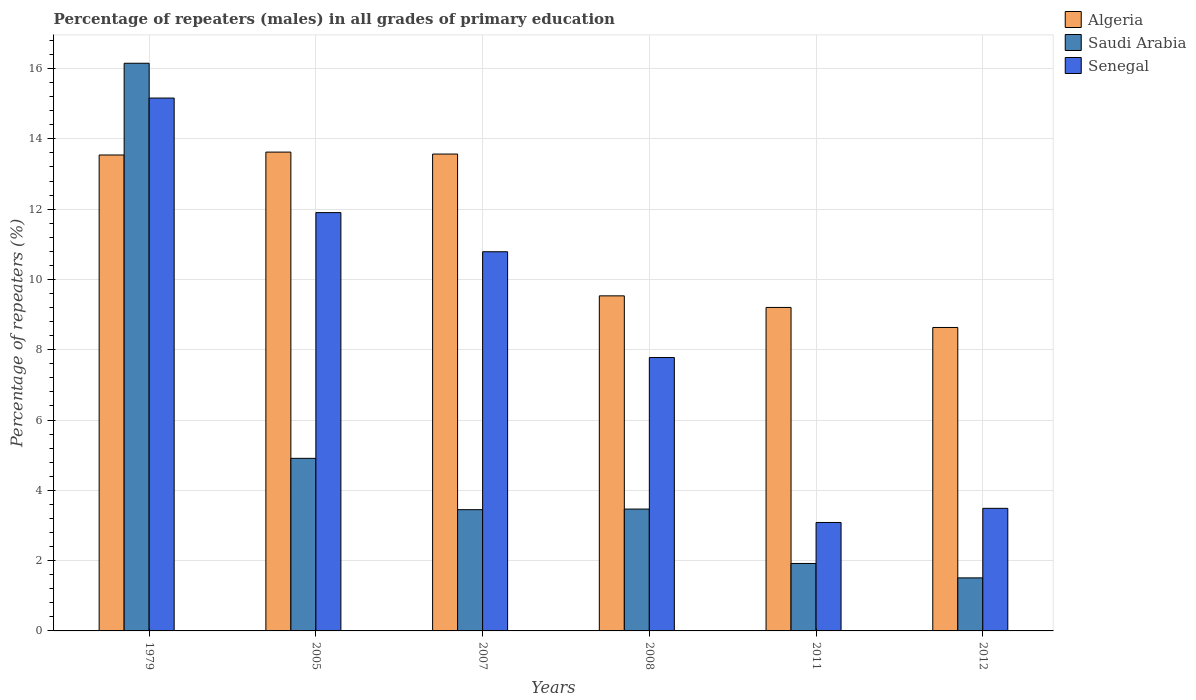How many groups of bars are there?
Ensure brevity in your answer.  6. Are the number of bars per tick equal to the number of legend labels?
Your answer should be compact. Yes. How many bars are there on the 1st tick from the left?
Offer a very short reply. 3. In how many cases, is the number of bars for a given year not equal to the number of legend labels?
Offer a very short reply. 0. What is the percentage of repeaters (males) in Senegal in 2007?
Provide a succinct answer. 10.79. Across all years, what is the maximum percentage of repeaters (males) in Senegal?
Give a very brief answer. 15.16. Across all years, what is the minimum percentage of repeaters (males) in Senegal?
Offer a very short reply. 3.09. In which year was the percentage of repeaters (males) in Algeria maximum?
Your answer should be very brief. 2005. What is the total percentage of repeaters (males) in Algeria in the graph?
Provide a succinct answer. 68.11. What is the difference between the percentage of repeaters (males) in Algeria in 2008 and that in 2012?
Provide a succinct answer. 0.9. What is the difference between the percentage of repeaters (males) in Saudi Arabia in 2011 and the percentage of repeaters (males) in Algeria in 2007?
Provide a short and direct response. -11.65. What is the average percentage of repeaters (males) in Senegal per year?
Your answer should be very brief. 8.7. In the year 2007, what is the difference between the percentage of repeaters (males) in Senegal and percentage of repeaters (males) in Algeria?
Your answer should be very brief. -2.78. In how many years, is the percentage of repeaters (males) in Senegal greater than 11.6 %?
Your response must be concise. 2. What is the ratio of the percentage of repeaters (males) in Saudi Arabia in 2008 to that in 2012?
Give a very brief answer. 2.3. Is the percentage of repeaters (males) in Algeria in 1979 less than that in 2008?
Ensure brevity in your answer.  No. Is the difference between the percentage of repeaters (males) in Senegal in 2008 and 2012 greater than the difference between the percentage of repeaters (males) in Algeria in 2008 and 2012?
Your answer should be very brief. Yes. What is the difference between the highest and the second highest percentage of repeaters (males) in Senegal?
Your answer should be very brief. 3.26. What is the difference between the highest and the lowest percentage of repeaters (males) in Algeria?
Offer a terse response. 4.99. In how many years, is the percentage of repeaters (males) in Senegal greater than the average percentage of repeaters (males) in Senegal taken over all years?
Offer a very short reply. 3. What does the 1st bar from the left in 2008 represents?
Your answer should be very brief. Algeria. What does the 2nd bar from the right in 2007 represents?
Your answer should be compact. Saudi Arabia. How many years are there in the graph?
Give a very brief answer. 6. Are the values on the major ticks of Y-axis written in scientific E-notation?
Give a very brief answer. No. Where does the legend appear in the graph?
Ensure brevity in your answer.  Top right. How many legend labels are there?
Give a very brief answer. 3. How are the legend labels stacked?
Offer a terse response. Vertical. What is the title of the graph?
Provide a succinct answer. Percentage of repeaters (males) in all grades of primary education. What is the label or title of the X-axis?
Give a very brief answer. Years. What is the label or title of the Y-axis?
Keep it short and to the point. Percentage of repeaters (%). What is the Percentage of repeaters (%) in Algeria in 1979?
Provide a succinct answer. 13.54. What is the Percentage of repeaters (%) of Saudi Arabia in 1979?
Your response must be concise. 16.15. What is the Percentage of repeaters (%) in Senegal in 1979?
Offer a very short reply. 15.16. What is the Percentage of repeaters (%) of Algeria in 2005?
Provide a short and direct response. 13.62. What is the Percentage of repeaters (%) in Saudi Arabia in 2005?
Your response must be concise. 4.91. What is the Percentage of repeaters (%) of Senegal in 2005?
Provide a succinct answer. 11.9. What is the Percentage of repeaters (%) in Algeria in 2007?
Offer a very short reply. 13.57. What is the Percentage of repeaters (%) in Saudi Arabia in 2007?
Make the answer very short. 3.45. What is the Percentage of repeaters (%) of Senegal in 2007?
Ensure brevity in your answer.  10.79. What is the Percentage of repeaters (%) of Algeria in 2008?
Your answer should be very brief. 9.53. What is the Percentage of repeaters (%) of Saudi Arabia in 2008?
Make the answer very short. 3.47. What is the Percentage of repeaters (%) of Senegal in 2008?
Your answer should be very brief. 7.78. What is the Percentage of repeaters (%) in Algeria in 2011?
Offer a very short reply. 9.2. What is the Percentage of repeaters (%) in Saudi Arabia in 2011?
Offer a terse response. 1.92. What is the Percentage of repeaters (%) in Senegal in 2011?
Offer a terse response. 3.09. What is the Percentage of repeaters (%) in Algeria in 2012?
Offer a very short reply. 8.63. What is the Percentage of repeaters (%) in Saudi Arabia in 2012?
Provide a short and direct response. 1.51. What is the Percentage of repeaters (%) of Senegal in 2012?
Ensure brevity in your answer.  3.49. Across all years, what is the maximum Percentage of repeaters (%) in Algeria?
Give a very brief answer. 13.62. Across all years, what is the maximum Percentage of repeaters (%) of Saudi Arabia?
Your response must be concise. 16.15. Across all years, what is the maximum Percentage of repeaters (%) in Senegal?
Your answer should be compact. 15.16. Across all years, what is the minimum Percentage of repeaters (%) of Algeria?
Your answer should be very brief. 8.63. Across all years, what is the minimum Percentage of repeaters (%) of Saudi Arabia?
Make the answer very short. 1.51. Across all years, what is the minimum Percentage of repeaters (%) in Senegal?
Provide a short and direct response. 3.09. What is the total Percentage of repeaters (%) of Algeria in the graph?
Offer a terse response. 68.11. What is the total Percentage of repeaters (%) of Saudi Arabia in the graph?
Your answer should be very brief. 31.41. What is the total Percentage of repeaters (%) of Senegal in the graph?
Keep it short and to the point. 52.21. What is the difference between the Percentage of repeaters (%) of Algeria in 1979 and that in 2005?
Your response must be concise. -0.08. What is the difference between the Percentage of repeaters (%) of Saudi Arabia in 1979 and that in 2005?
Offer a terse response. 11.24. What is the difference between the Percentage of repeaters (%) of Senegal in 1979 and that in 2005?
Provide a short and direct response. 3.26. What is the difference between the Percentage of repeaters (%) in Algeria in 1979 and that in 2007?
Provide a short and direct response. -0.03. What is the difference between the Percentage of repeaters (%) in Saudi Arabia in 1979 and that in 2007?
Offer a very short reply. 12.7. What is the difference between the Percentage of repeaters (%) of Senegal in 1979 and that in 2007?
Keep it short and to the point. 4.37. What is the difference between the Percentage of repeaters (%) of Algeria in 1979 and that in 2008?
Your answer should be very brief. 4.01. What is the difference between the Percentage of repeaters (%) in Saudi Arabia in 1979 and that in 2008?
Offer a very short reply. 12.68. What is the difference between the Percentage of repeaters (%) of Senegal in 1979 and that in 2008?
Provide a short and direct response. 7.38. What is the difference between the Percentage of repeaters (%) of Algeria in 1979 and that in 2011?
Make the answer very short. 4.34. What is the difference between the Percentage of repeaters (%) of Saudi Arabia in 1979 and that in 2011?
Your answer should be compact. 14.23. What is the difference between the Percentage of repeaters (%) in Senegal in 1979 and that in 2011?
Offer a terse response. 12.08. What is the difference between the Percentage of repeaters (%) in Algeria in 1979 and that in 2012?
Provide a short and direct response. 4.91. What is the difference between the Percentage of repeaters (%) of Saudi Arabia in 1979 and that in 2012?
Offer a terse response. 14.64. What is the difference between the Percentage of repeaters (%) in Senegal in 1979 and that in 2012?
Offer a terse response. 11.67. What is the difference between the Percentage of repeaters (%) in Algeria in 2005 and that in 2007?
Offer a terse response. 0.06. What is the difference between the Percentage of repeaters (%) of Saudi Arabia in 2005 and that in 2007?
Make the answer very short. 1.46. What is the difference between the Percentage of repeaters (%) of Senegal in 2005 and that in 2007?
Keep it short and to the point. 1.11. What is the difference between the Percentage of repeaters (%) in Algeria in 2005 and that in 2008?
Ensure brevity in your answer.  4.09. What is the difference between the Percentage of repeaters (%) of Saudi Arabia in 2005 and that in 2008?
Your answer should be very brief. 1.44. What is the difference between the Percentage of repeaters (%) of Senegal in 2005 and that in 2008?
Ensure brevity in your answer.  4.12. What is the difference between the Percentage of repeaters (%) in Algeria in 2005 and that in 2011?
Offer a very short reply. 4.42. What is the difference between the Percentage of repeaters (%) in Saudi Arabia in 2005 and that in 2011?
Offer a very short reply. 2.99. What is the difference between the Percentage of repeaters (%) in Senegal in 2005 and that in 2011?
Give a very brief answer. 8.82. What is the difference between the Percentage of repeaters (%) of Algeria in 2005 and that in 2012?
Your answer should be compact. 4.99. What is the difference between the Percentage of repeaters (%) of Saudi Arabia in 2005 and that in 2012?
Make the answer very short. 3.4. What is the difference between the Percentage of repeaters (%) of Senegal in 2005 and that in 2012?
Keep it short and to the point. 8.41. What is the difference between the Percentage of repeaters (%) of Algeria in 2007 and that in 2008?
Your answer should be compact. 4.03. What is the difference between the Percentage of repeaters (%) of Saudi Arabia in 2007 and that in 2008?
Your answer should be very brief. -0.02. What is the difference between the Percentage of repeaters (%) in Senegal in 2007 and that in 2008?
Give a very brief answer. 3.01. What is the difference between the Percentage of repeaters (%) of Algeria in 2007 and that in 2011?
Give a very brief answer. 4.36. What is the difference between the Percentage of repeaters (%) of Saudi Arabia in 2007 and that in 2011?
Your response must be concise. 1.53. What is the difference between the Percentage of repeaters (%) in Senegal in 2007 and that in 2011?
Give a very brief answer. 7.7. What is the difference between the Percentage of repeaters (%) of Algeria in 2007 and that in 2012?
Your answer should be very brief. 4.93. What is the difference between the Percentage of repeaters (%) in Saudi Arabia in 2007 and that in 2012?
Give a very brief answer. 1.94. What is the difference between the Percentage of repeaters (%) of Senegal in 2007 and that in 2012?
Make the answer very short. 7.3. What is the difference between the Percentage of repeaters (%) of Algeria in 2008 and that in 2011?
Offer a very short reply. 0.33. What is the difference between the Percentage of repeaters (%) of Saudi Arabia in 2008 and that in 2011?
Offer a very short reply. 1.55. What is the difference between the Percentage of repeaters (%) in Senegal in 2008 and that in 2011?
Your answer should be compact. 4.69. What is the difference between the Percentage of repeaters (%) in Algeria in 2008 and that in 2012?
Offer a terse response. 0.9. What is the difference between the Percentage of repeaters (%) in Saudi Arabia in 2008 and that in 2012?
Your answer should be very brief. 1.96. What is the difference between the Percentage of repeaters (%) of Senegal in 2008 and that in 2012?
Keep it short and to the point. 4.29. What is the difference between the Percentage of repeaters (%) in Algeria in 2011 and that in 2012?
Offer a terse response. 0.57. What is the difference between the Percentage of repeaters (%) of Saudi Arabia in 2011 and that in 2012?
Provide a succinct answer. 0.41. What is the difference between the Percentage of repeaters (%) in Senegal in 2011 and that in 2012?
Offer a terse response. -0.4. What is the difference between the Percentage of repeaters (%) of Algeria in 1979 and the Percentage of repeaters (%) of Saudi Arabia in 2005?
Make the answer very short. 8.63. What is the difference between the Percentage of repeaters (%) of Algeria in 1979 and the Percentage of repeaters (%) of Senegal in 2005?
Provide a short and direct response. 1.64. What is the difference between the Percentage of repeaters (%) of Saudi Arabia in 1979 and the Percentage of repeaters (%) of Senegal in 2005?
Your answer should be compact. 4.25. What is the difference between the Percentage of repeaters (%) of Algeria in 1979 and the Percentage of repeaters (%) of Saudi Arabia in 2007?
Give a very brief answer. 10.09. What is the difference between the Percentage of repeaters (%) of Algeria in 1979 and the Percentage of repeaters (%) of Senegal in 2007?
Keep it short and to the point. 2.75. What is the difference between the Percentage of repeaters (%) in Saudi Arabia in 1979 and the Percentage of repeaters (%) in Senegal in 2007?
Offer a very short reply. 5.36. What is the difference between the Percentage of repeaters (%) in Algeria in 1979 and the Percentage of repeaters (%) in Saudi Arabia in 2008?
Make the answer very short. 10.07. What is the difference between the Percentage of repeaters (%) of Algeria in 1979 and the Percentage of repeaters (%) of Senegal in 2008?
Ensure brevity in your answer.  5.76. What is the difference between the Percentage of repeaters (%) in Saudi Arabia in 1979 and the Percentage of repeaters (%) in Senegal in 2008?
Provide a succinct answer. 8.37. What is the difference between the Percentage of repeaters (%) in Algeria in 1979 and the Percentage of repeaters (%) in Saudi Arabia in 2011?
Your answer should be compact. 11.62. What is the difference between the Percentage of repeaters (%) of Algeria in 1979 and the Percentage of repeaters (%) of Senegal in 2011?
Your answer should be compact. 10.46. What is the difference between the Percentage of repeaters (%) in Saudi Arabia in 1979 and the Percentage of repeaters (%) in Senegal in 2011?
Your response must be concise. 13.07. What is the difference between the Percentage of repeaters (%) of Algeria in 1979 and the Percentage of repeaters (%) of Saudi Arabia in 2012?
Provide a succinct answer. 12.03. What is the difference between the Percentage of repeaters (%) in Algeria in 1979 and the Percentage of repeaters (%) in Senegal in 2012?
Keep it short and to the point. 10.05. What is the difference between the Percentage of repeaters (%) in Saudi Arabia in 1979 and the Percentage of repeaters (%) in Senegal in 2012?
Ensure brevity in your answer.  12.66. What is the difference between the Percentage of repeaters (%) in Algeria in 2005 and the Percentage of repeaters (%) in Saudi Arabia in 2007?
Provide a succinct answer. 10.17. What is the difference between the Percentage of repeaters (%) of Algeria in 2005 and the Percentage of repeaters (%) of Senegal in 2007?
Make the answer very short. 2.84. What is the difference between the Percentage of repeaters (%) in Saudi Arabia in 2005 and the Percentage of repeaters (%) in Senegal in 2007?
Provide a short and direct response. -5.88. What is the difference between the Percentage of repeaters (%) of Algeria in 2005 and the Percentage of repeaters (%) of Saudi Arabia in 2008?
Keep it short and to the point. 10.16. What is the difference between the Percentage of repeaters (%) in Algeria in 2005 and the Percentage of repeaters (%) in Senegal in 2008?
Make the answer very short. 5.84. What is the difference between the Percentage of repeaters (%) of Saudi Arabia in 2005 and the Percentage of repeaters (%) of Senegal in 2008?
Keep it short and to the point. -2.87. What is the difference between the Percentage of repeaters (%) in Algeria in 2005 and the Percentage of repeaters (%) in Saudi Arabia in 2011?
Ensure brevity in your answer.  11.7. What is the difference between the Percentage of repeaters (%) in Algeria in 2005 and the Percentage of repeaters (%) in Senegal in 2011?
Offer a very short reply. 10.54. What is the difference between the Percentage of repeaters (%) in Saudi Arabia in 2005 and the Percentage of repeaters (%) in Senegal in 2011?
Provide a succinct answer. 1.82. What is the difference between the Percentage of repeaters (%) in Algeria in 2005 and the Percentage of repeaters (%) in Saudi Arabia in 2012?
Keep it short and to the point. 12.12. What is the difference between the Percentage of repeaters (%) in Algeria in 2005 and the Percentage of repeaters (%) in Senegal in 2012?
Ensure brevity in your answer.  10.14. What is the difference between the Percentage of repeaters (%) in Saudi Arabia in 2005 and the Percentage of repeaters (%) in Senegal in 2012?
Ensure brevity in your answer.  1.42. What is the difference between the Percentage of repeaters (%) of Algeria in 2007 and the Percentage of repeaters (%) of Saudi Arabia in 2008?
Your response must be concise. 10.1. What is the difference between the Percentage of repeaters (%) in Algeria in 2007 and the Percentage of repeaters (%) in Senegal in 2008?
Offer a very short reply. 5.79. What is the difference between the Percentage of repeaters (%) in Saudi Arabia in 2007 and the Percentage of repeaters (%) in Senegal in 2008?
Provide a short and direct response. -4.33. What is the difference between the Percentage of repeaters (%) in Algeria in 2007 and the Percentage of repeaters (%) in Saudi Arabia in 2011?
Give a very brief answer. 11.65. What is the difference between the Percentage of repeaters (%) of Algeria in 2007 and the Percentage of repeaters (%) of Senegal in 2011?
Offer a terse response. 10.48. What is the difference between the Percentage of repeaters (%) of Saudi Arabia in 2007 and the Percentage of repeaters (%) of Senegal in 2011?
Make the answer very short. 0.36. What is the difference between the Percentage of repeaters (%) of Algeria in 2007 and the Percentage of repeaters (%) of Saudi Arabia in 2012?
Provide a short and direct response. 12.06. What is the difference between the Percentage of repeaters (%) in Algeria in 2007 and the Percentage of repeaters (%) in Senegal in 2012?
Ensure brevity in your answer.  10.08. What is the difference between the Percentage of repeaters (%) in Saudi Arabia in 2007 and the Percentage of repeaters (%) in Senegal in 2012?
Your answer should be very brief. -0.04. What is the difference between the Percentage of repeaters (%) of Algeria in 2008 and the Percentage of repeaters (%) of Saudi Arabia in 2011?
Provide a succinct answer. 7.61. What is the difference between the Percentage of repeaters (%) of Algeria in 2008 and the Percentage of repeaters (%) of Senegal in 2011?
Your answer should be compact. 6.45. What is the difference between the Percentage of repeaters (%) of Saudi Arabia in 2008 and the Percentage of repeaters (%) of Senegal in 2011?
Provide a short and direct response. 0.38. What is the difference between the Percentage of repeaters (%) of Algeria in 2008 and the Percentage of repeaters (%) of Saudi Arabia in 2012?
Your answer should be very brief. 8.02. What is the difference between the Percentage of repeaters (%) of Algeria in 2008 and the Percentage of repeaters (%) of Senegal in 2012?
Offer a very short reply. 6.05. What is the difference between the Percentage of repeaters (%) in Saudi Arabia in 2008 and the Percentage of repeaters (%) in Senegal in 2012?
Give a very brief answer. -0.02. What is the difference between the Percentage of repeaters (%) in Algeria in 2011 and the Percentage of repeaters (%) in Saudi Arabia in 2012?
Give a very brief answer. 7.69. What is the difference between the Percentage of repeaters (%) of Algeria in 2011 and the Percentage of repeaters (%) of Senegal in 2012?
Give a very brief answer. 5.72. What is the difference between the Percentage of repeaters (%) in Saudi Arabia in 2011 and the Percentage of repeaters (%) in Senegal in 2012?
Provide a succinct answer. -1.57. What is the average Percentage of repeaters (%) in Algeria per year?
Give a very brief answer. 11.35. What is the average Percentage of repeaters (%) of Saudi Arabia per year?
Offer a terse response. 5.23. What is the average Percentage of repeaters (%) of Senegal per year?
Provide a succinct answer. 8.7. In the year 1979, what is the difference between the Percentage of repeaters (%) in Algeria and Percentage of repeaters (%) in Saudi Arabia?
Keep it short and to the point. -2.61. In the year 1979, what is the difference between the Percentage of repeaters (%) of Algeria and Percentage of repeaters (%) of Senegal?
Provide a short and direct response. -1.62. In the year 1979, what is the difference between the Percentage of repeaters (%) of Saudi Arabia and Percentage of repeaters (%) of Senegal?
Your answer should be compact. 0.99. In the year 2005, what is the difference between the Percentage of repeaters (%) of Algeria and Percentage of repeaters (%) of Saudi Arabia?
Your response must be concise. 8.71. In the year 2005, what is the difference between the Percentage of repeaters (%) of Algeria and Percentage of repeaters (%) of Senegal?
Keep it short and to the point. 1.72. In the year 2005, what is the difference between the Percentage of repeaters (%) of Saudi Arabia and Percentage of repeaters (%) of Senegal?
Ensure brevity in your answer.  -6.99. In the year 2007, what is the difference between the Percentage of repeaters (%) of Algeria and Percentage of repeaters (%) of Saudi Arabia?
Keep it short and to the point. 10.12. In the year 2007, what is the difference between the Percentage of repeaters (%) in Algeria and Percentage of repeaters (%) in Senegal?
Offer a very short reply. 2.78. In the year 2007, what is the difference between the Percentage of repeaters (%) of Saudi Arabia and Percentage of repeaters (%) of Senegal?
Provide a short and direct response. -7.34. In the year 2008, what is the difference between the Percentage of repeaters (%) in Algeria and Percentage of repeaters (%) in Saudi Arabia?
Provide a short and direct response. 6.07. In the year 2008, what is the difference between the Percentage of repeaters (%) in Algeria and Percentage of repeaters (%) in Senegal?
Offer a very short reply. 1.75. In the year 2008, what is the difference between the Percentage of repeaters (%) in Saudi Arabia and Percentage of repeaters (%) in Senegal?
Make the answer very short. -4.31. In the year 2011, what is the difference between the Percentage of repeaters (%) in Algeria and Percentage of repeaters (%) in Saudi Arabia?
Your response must be concise. 7.28. In the year 2011, what is the difference between the Percentage of repeaters (%) of Algeria and Percentage of repeaters (%) of Senegal?
Make the answer very short. 6.12. In the year 2011, what is the difference between the Percentage of repeaters (%) of Saudi Arabia and Percentage of repeaters (%) of Senegal?
Provide a short and direct response. -1.17. In the year 2012, what is the difference between the Percentage of repeaters (%) in Algeria and Percentage of repeaters (%) in Saudi Arabia?
Offer a terse response. 7.12. In the year 2012, what is the difference between the Percentage of repeaters (%) of Algeria and Percentage of repeaters (%) of Senegal?
Your response must be concise. 5.15. In the year 2012, what is the difference between the Percentage of repeaters (%) in Saudi Arabia and Percentage of repeaters (%) in Senegal?
Your answer should be compact. -1.98. What is the ratio of the Percentage of repeaters (%) in Saudi Arabia in 1979 to that in 2005?
Keep it short and to the point. 3.29. What is the ratio of the Percentage of repeaters (%) of Senegal in 1979 to that in 2005?
Your answer should be compact. 1.27. What is the ratio of the Percentage of repeaters (%) of Saudi Arabia in 1979 to that in 2007?
Keep it short and to the point. 4.68. What is the ratio of the Percentage of repeaters (%) in Senegal in 1979 to that in 2007?
Ensure brevity in your answer.  1.41. What is the ratio of the Percentage of repeaters (%) of Algeria in 1979 to that in 2008?
Offer a terse response. 1.42. What is the ratio of the Percentage of repeaters (%) in Saudi Arabia in 1979 to that in 2008?
Offer a terse response. 4.66. What is the ratio of the Percentage of repeaters (%) in Senegal in 1979 to that in 2008?
Provide a succinct answer. 1.95. What is the ratio of the Percentage of repeaters (%) in Algeria in 1979 to that in 2011?
Offer a very short reply. 1.47. What is the ratio of the Percentage of repeaters (%) in Saudi Arabia in 1979 to that in 2011?
Your response must be concise. 8.42. What is the ratio of the Percentage of repeaters (%) of Senegal in 1979 to that in 2011?
Offer a terse response. 4.91. What is the ratio of the Percentage of repeaters (%) of Algeria in 1979 to that in 2012?
Your answer should be very brief. 1.57. What is the ratio of the Percentage of repeaters (%) of Saudi Arabia in 1979 to that in 2012?
Keep it short and to the point. 10.7. What is the ratio of the Percentage of repeaters (%) of Senegal in 1979 to that in 2012?
Keep it short and to the point. 4.35. What is the ratio of the Percentage of repeaters (%) in Algeria in 2005 to that in 2007?
Keep it short and to the point. 1. What is the ratio of the Percentage of repeaters (%) in Saudi Arabia in 2005 to that in 2007?
Make the answer very short. 1.42. What is the ratio of the Percentage of repeaters (%) of Senegal in 2005 to that in 2007?
Your answer should be very brief. 1.1. What is the ratio of the Percentage of repeaters (%) of Algeria in 2005 to that in 2008?
Offer a very short reply. 1.43. What is the ratio of the Percentage of repeaters (%) in Saudi Arabia in 2005 to that in 2008?
Ensure brevity in your answer.  1.42. What is the ratio of the Percentage of repeaters (%) of Senegal in 2005 to that in 2008?
Provide a short and direct response. 1.53. What is the ratio of the Percentage of repeaters (%) in Algeria in 2005 to that in 2011?
Ensure brevity in your answer.  1.48. What is the ratio of the Percentage of repeaters (%) of Saudi Arabia in 2005 to that in 2011?
Give a very brief answer. 2.56. What is the ratio of the Percentage of repeaters (%) of Senegal in 2005 to that in 2011?
Ensure brevity in your answer.  3.86. What is the ratio of the Percentage of repeaters (%) of Algeria in 2005 to that in 2012?
Ensure brevity in your answer.  1.58. What is the ratio of the Percentage of repeaters (%) of Saudi Arabia in 2005 to that in 2012?
Ensure brevity in your answer.  3.25. What is the ratio of the Percentage of repeaters (%) in Senegal in 2005 to that in 2012?
Give a very brief answer. 3.41. What is the ratio of the Percentage of repeaters (%) of Algeria in 2007 to that in 2008?
Your answer should be very brief. 1.42. What is the ratio of the Percentage of repeaters (%) of Saudi Arabia in 2007 to that in 2008?
Ensure brevity in your answer.  0.99. What is the ratio of the Percentage of repeaters (%) in Senegal in 2007 to that in 2008?
Your answer should be compact. 1.39. What is the ratio of the Percentage of repeaters (%) of Algeria in 2007 to that in 2011?
Provide a short and direct response. 1.47. What is the ratio of the Percentage of repeaters (%) in Saudi Arabia in 2007 to that in 2011?
Provide a short and direct response. 1.8. What is the ratio of the Percentage of repeaters (%) in Senegal in 2007 to that in 2011?
Ensure brevity in your answer.  3.5. What is the ratio of the Percentage of repeaters (%) of Algeria in 2007 to that in 2012?
Your response must be concise. 1.57. What is the ratio of the Percentage of repeaters (%) of Saudi Arabia in 2007 to that in 2012?
Your response must be concise. 2.29. What is the ratio of the Percentage of repeaters (%) in Senegal in 2007 to that in 2012?
Your response must be concise. 3.09. What is the ratio of the Percentage of repeaters (%) in Algeria in 2008 to that in 2011?
Provide a succinct answer. 1.04. What is the ratio of the Percentage of repeaters (%) of Saudi Arabia in 2008 to that in 2011?
Keep it short and to the point. 1.81. What is the ratio of the Percentage of repeaters (%) of Senegal in 2008 to that in 2011?
Offer a very short reply. 2.52. What is the ratio of the Percentage of repeaters (%) in Algeria in 2008 to that in 2012?
Your answer should be very brief. 1.1. What is the ratio of the Percentage of repeaters (%) in Saudi Arabia in 2008 to that in 2012?
Your response must be concise. 2.3. What is the ratio of the Percentage of repeaters (%) of Senegal in 2008 to that in 2012?
Your response must be concise. 2.23. What is the ratio of the Percentage of repeaters (%) of Algeria in 2011 to that in 2012?
Offer a terse response. 1.07. What is the ratio of the Percentage of repeaters (%) of Saudi Arabia in 2011 to that in 2012?
Offer a very short reply. 1.27. What is the ratio of the Percentage of repeaters (%) in Senegal in 2011 to that in 2012?
Your response must be concise. 0.88. What is the difference between the highest and the second highest Percentage of repeaters (%) in Algeria?
Offer a terse response. 0.06. What is the difference between the highest and the second highest Percentage of repeaters (%) of Saudi Arabia?
Ensure brevity in your answer.  11.24. What is the difference between the highest and the second highest Percentage of repeaters (%) of Senegal?
Give a very brief answer. 3.26. What is the difference between the highest and the lowest Percentage of repeaters (%) of Algeria?
Your response must be concise. 4.99. What is the difference between the highest and the lowest Percentage of repeaters (%) in Saudi Arabia?
Your response must be concise. 14.64. What is the difference between the highest and the lowest Percentage of repeaters (%) of Senegal?
Your answer should be very brief. 12.08. 